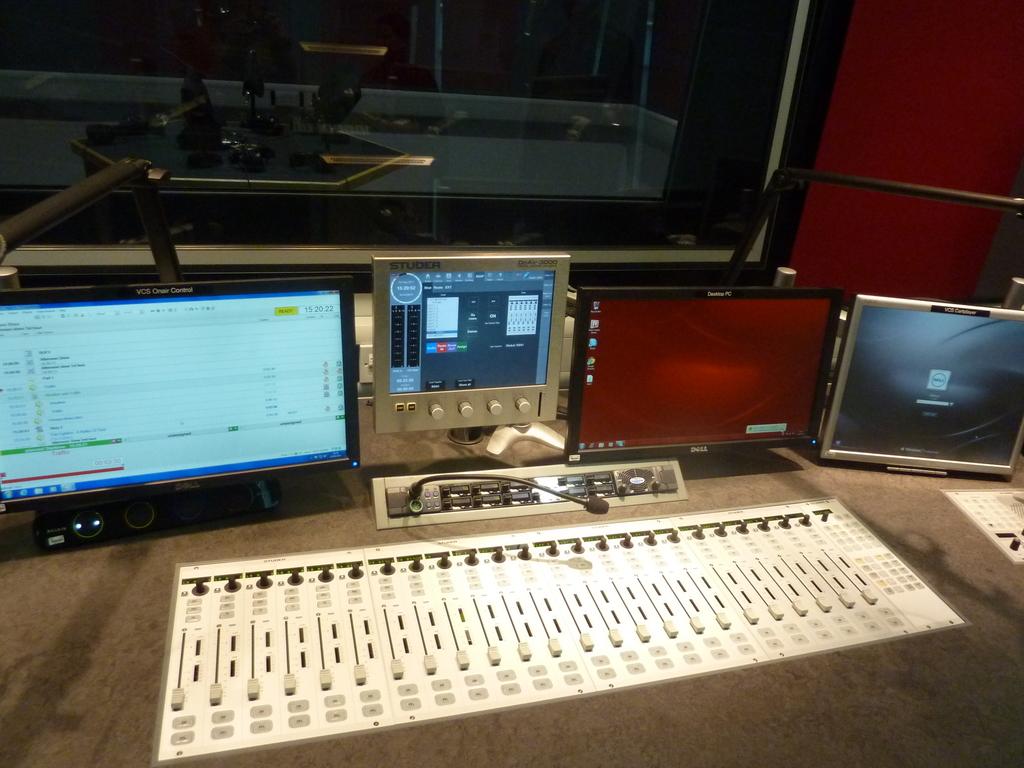What does the text in bold say?
Provide a succinct answer. Unanswerable. What is the brand of computer monitor?
Give a very brief answer. Dell. 